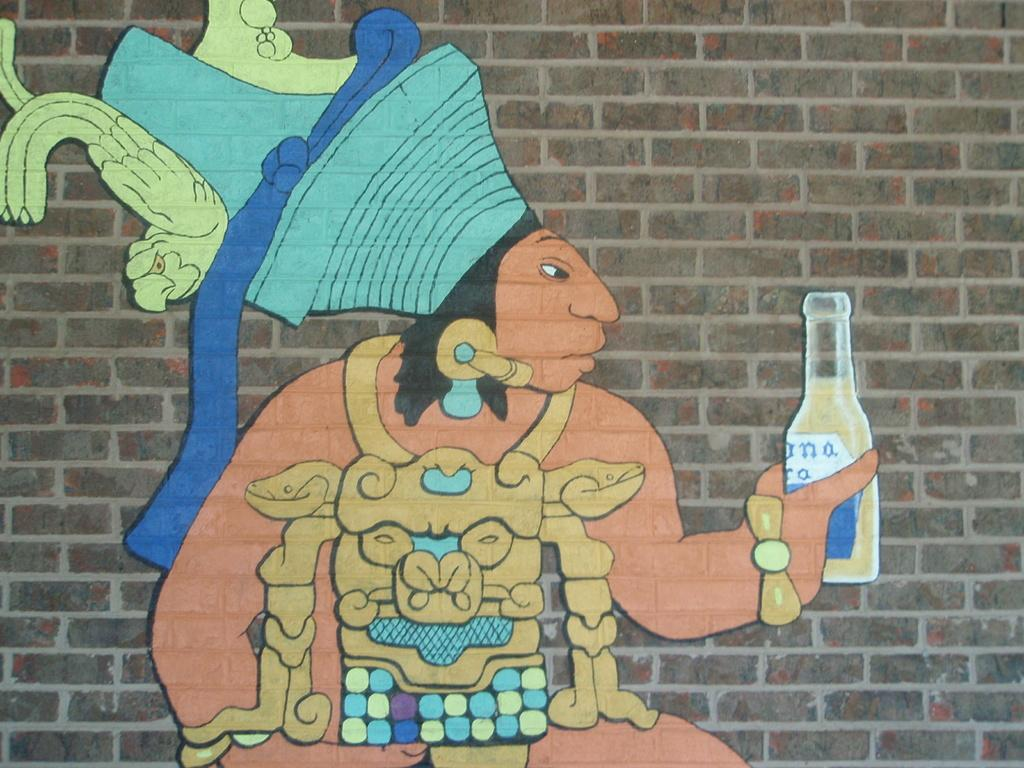Provide a one-sentence caption for the provided image. A graffiti art image on a brick wall of a south american mayan type figure holding a corona. 